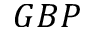<formula> <loc_0><loc_0><loc_500><loc_500>G B P</formula> 